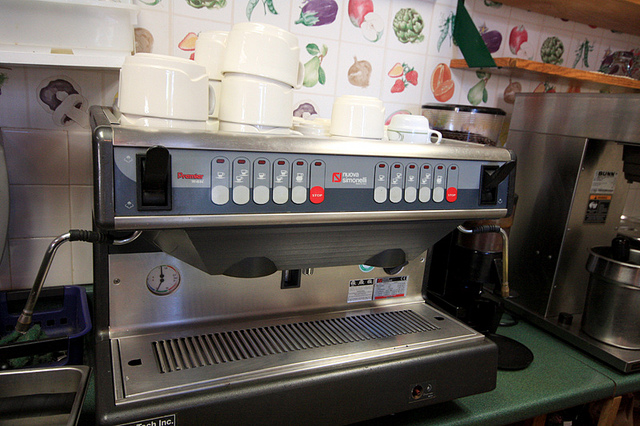Are there any unique features visible on this machine that you can tell me about? Certainly! The machine features multiple group heads, which allow baristas to make several espresso shots simultaneously. There's also a pressure gauge, indicative of the machine's ability to precisely control the brewing process for optimal espresso extraction. 